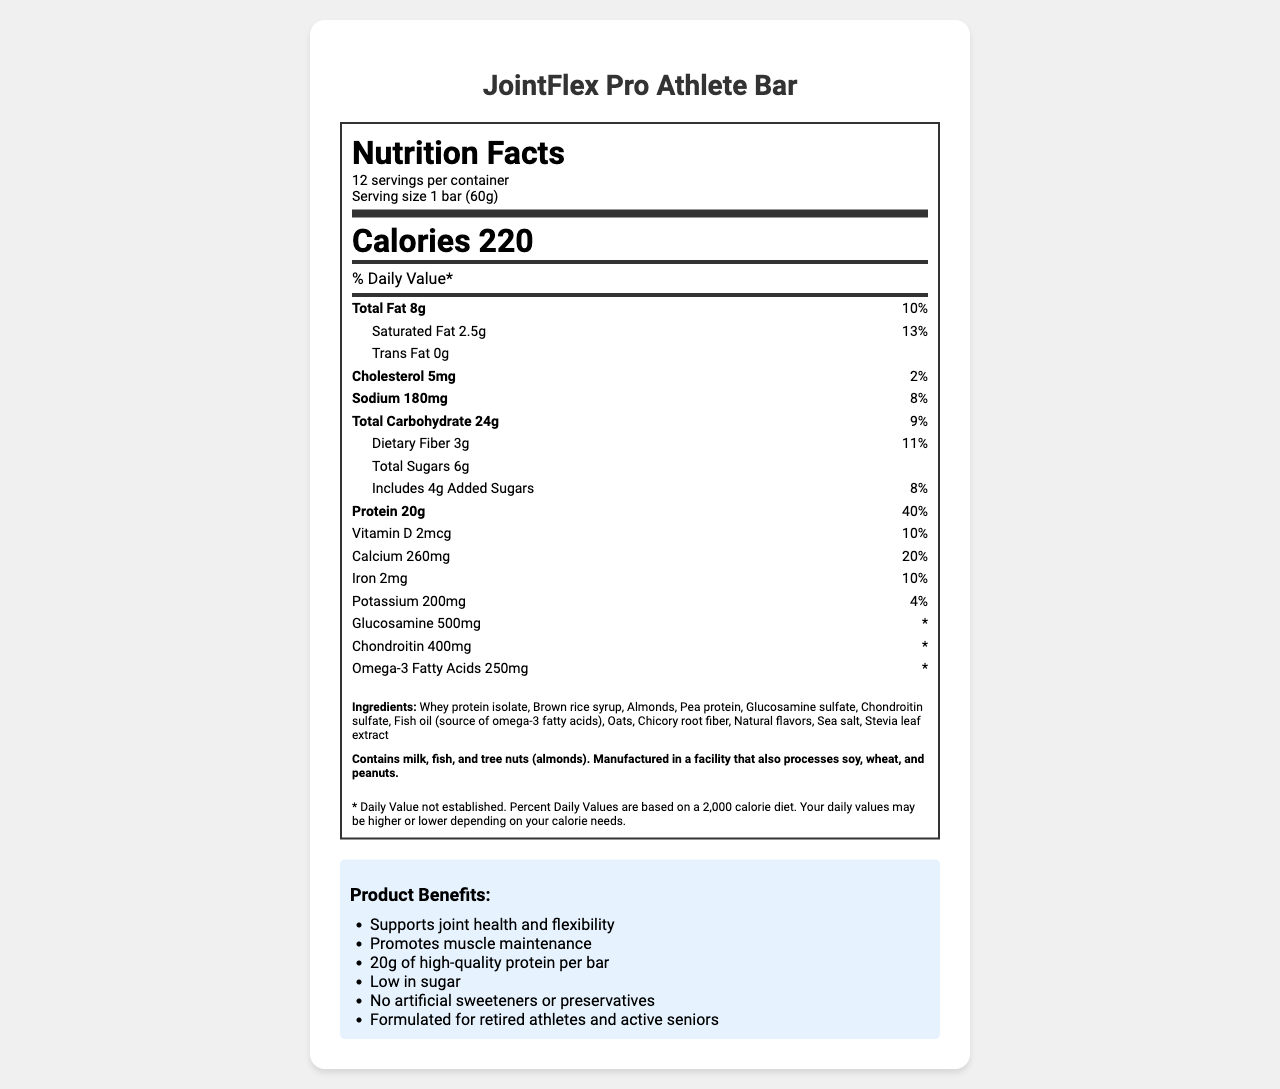What is the serving size of the JointFlex Pro Athlete Bar? The serving size is explicitly listed on the document as "1 bar (60g)".
Answer: 1 bar (60g) How many servings are there per container? The document mentions that there are 12 servings per container.
Answer: 12 What is the daily value percentage for protein? The document specifies that the daily value percentage for protein is 40%.
Answer: 40% Which ingredients are sources of protein in the bar? The ingredient list includes "Whey protein isolate" and "Pea protein", which are common sources of protein.
Answer: Whey protein isolate, Pea protein How much dietary fiber does the bar contain? The dietary fiber content is listed as 3g in the document.
Answer: 3g What are the total sugars in the JointFlex Pro Athlete Bar? The document states that the total sugars content is 6g.
Answer: 6g How much calcium does one bar provide? A. 100mg B. 200mg C. 260mg D. 500mg The document mentions that one bar provides 260mg of calcium.
Answer: C. 260mg Which of the following claims is highlighted about the JointFlex Pro Athlete Bar? A. No added sugars B. Supports immune health C. Supports joint health and flexibility D. Gluten-free The marketing claims section mentions "Supports joint health and flexibility".
Answer: C. Supports joint health and flexibility Is the protein bar suitable for someone with a peanut allergy? The allergen information states that the bar is manufactured in a facility that processes peanuts.
Answer: No Summarize the main idea of the JointFlex Pro Athlete Bar document. The document describes the nutritional content, ingredients, benefits, and allergen information of the JointFlex Pro Athlete Bar, emphasizing its suitability for retired athletes and its joint health benefits.
Answer: The JointFlex Pro Athlete Bar is a high-protein bar designed for retired athletes and active seniors, containing ingredients that support joint health, flexibility, and muscle maintenance. It provides 220 calories per serving with notable nutrients such as 20g of protein, 260mg of calcium, 500mg of glucosamine, and 400mg of chondroitin. The bar is low in sugar and contains no artificial sweeteners or preservatives. What is the form of omega-3 fatty acids present in the protein bar? The ingredient list includes "Fish oil (source of omega-3 fatty acids)".
Answer: Fish oil How many calories are there in one serving of the JointFlex Pro Athlete Bar? The document states that there are 220 calories in one serving.
Answer: 220 Identify the artificial sweeteners or preservatives listed in the ingredients. The ingredient list mentions no artificial sweeteners or preservatives, and the marketing claims confirm this.
Answer: None What is the total fat content per bar? The total fat content per bar is listed as 8g.
Answer: 8g Can you determine the exact amount of omega-3 fatty acids required daily from this document? The document lists the amount of omega-3 fatty acids in the bar, but it does not specify the daily requirement.
Answer: Not enough information 